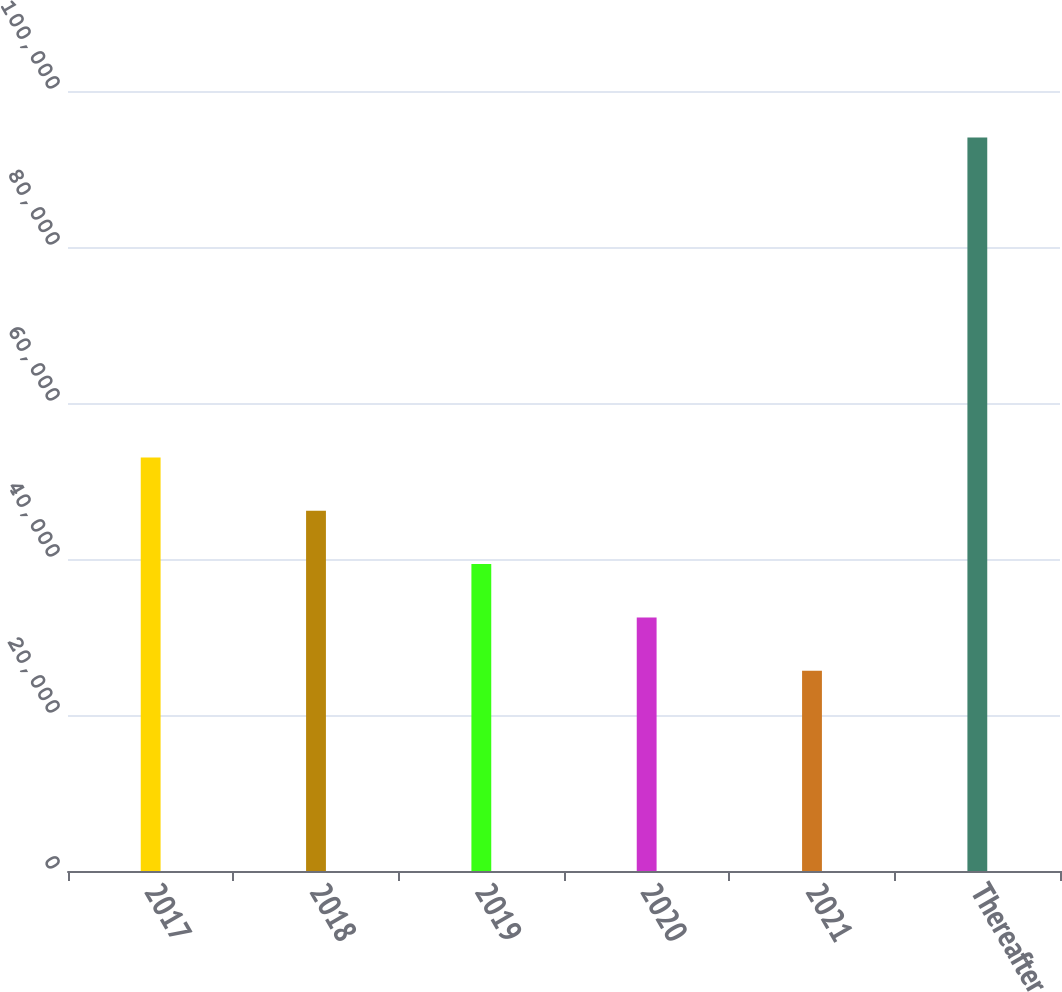<chart> <loc_0><loc_0><loc_500><loc_500><bar_chart><fcel>2017<fcel>2018<fcel>2019<fcel>2020<fcel>2021<fcel>Thereafter<nl><fcel>53021.6<fcel>46183.7<fcel>39345.8<fcel>32507.9<fcel>25670<fcel>94049<nl></chart> 